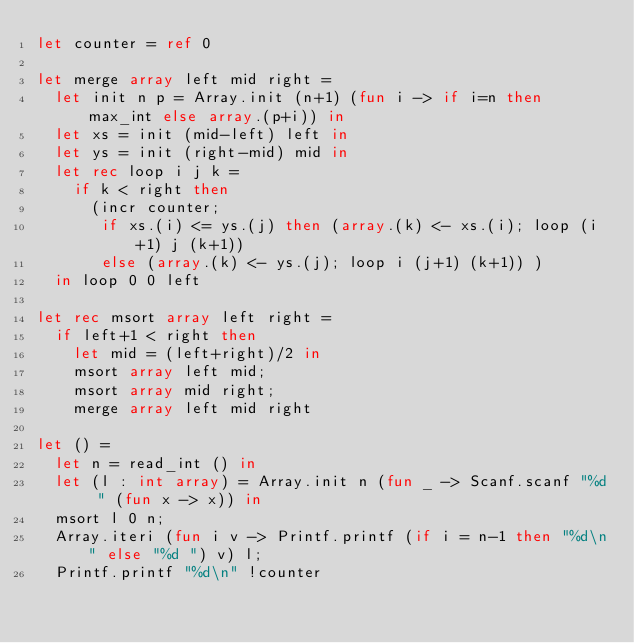<code> <loc_0><loc_0><loc_500><loc_500><_OCaml_>let counter = ref 0

let merge array left mid right =
  let init n p = Array.init (n+1) (fun i -> if i=n then max_int else array.(p+i)) in
  let xs = init (mid-left) left in
  let ys = init (right-mid) mid in
  let rec loop i j k =
    if k < right then
      (incr counter;
       if xs.(i) <= ys.(j) then (array.(k) <- xs.(i); loop (i+1) j (k+1))
       else (array.(k) <- ys.(j); loop i (j+1) (k+1)) )
  in loop 0 0 left

let rec msort array left right =
  if left+1 < right then
    let mid = (left+right)/2 in
    msort array left mid;
    msort array mid right;
    merge array left mid right

let () =
  let n = read_int () in
  let (l : int array) = Array.init n (fun _ -> Scanf.scanf "%d " (fun x -> x)) in
  msort l 0 n;
  Array.iteri (fun i v -> Printf.printf (if i = n-1 then "%d\n" else "%d ") v) l;
  Printf.printf "%d\n" !counter</code> 